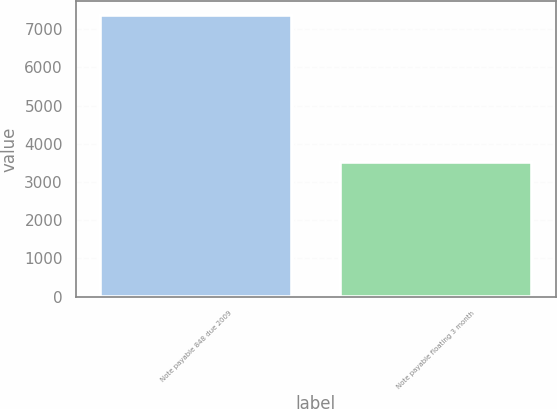<chart> <loc_0><loc_0><loc_500><loc_500><bar_chart><fcel>Note payable 848 due 2009<fcel>Note payable floating 3 month<nl><fcel>7363<fcel>3523<nl></chart> 